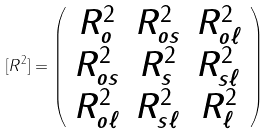Convert formula to latex. <formula><loc_0><loc_0><loc_500><loc_500>[ R ^ { 2 } ] = \left ( \begin{array} { c c c } R _ { o } ^ { 2 } & R _ { o s } ^ { 2 } & R _ { o \ell } ^ { 2 } \\ R _ { o s } ^ { 2 } & R _ { s } ^ { 2 } & R _ { s \ell } ^ { 2 } \\ R _ { o \ell } ^ { 2 } & R _ { s \ell } ^ { 2 } & R _ { \ell } ^ { 2 } \end{array} \right )</formula> 